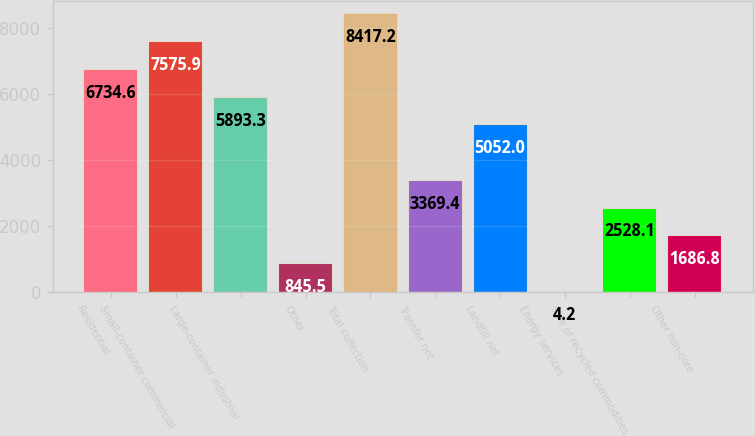Convert chart. <chart><loc_0><loc_0><loc_500><loc_500><bar_chart><fcel>Residential<fcel>Small-container commercial<fcel>Large-container industrial<fcel>Other<fcel>Total collection<fcel>Transfer net<fcel>Landfill net<fcel>Energy services<fcel>Sale of recycled commodities<fcel>Other non-core<nl><fcel>6734.6<fcel>7575.9<fcel>5893.3<fcel>845.5<fcel>8417.2<fcel>3369.4<fcel>5052<fcel>4.2<fcel>2528.1<fcel>1686.8<nl></chart> 